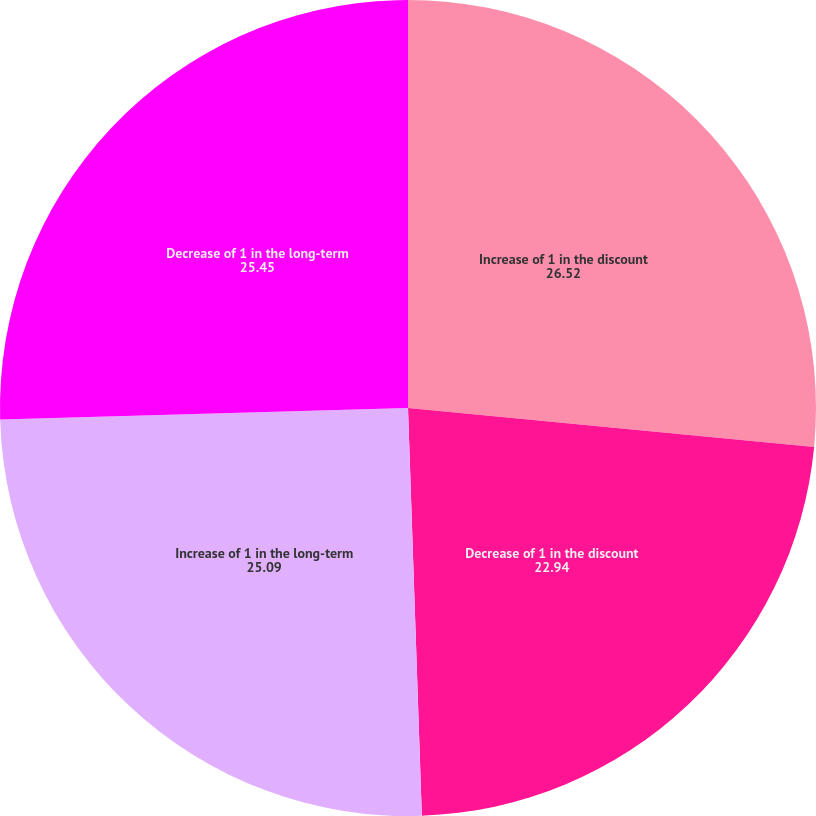Convert chart to OTSL. <chart><loc_0><loc_0><loc_500><loc_500><pie_chart><fcel>Increase of 1 in the discount<fcel>Decrease of 1 in the discount<fcel>Increase of 1 in the long-term<fcel>Decrease of 1 in the long-term<nl><fcel>26.52%<fcel>22.94%<fcel>25.09%<fcel>25.45%<nl></chart> 